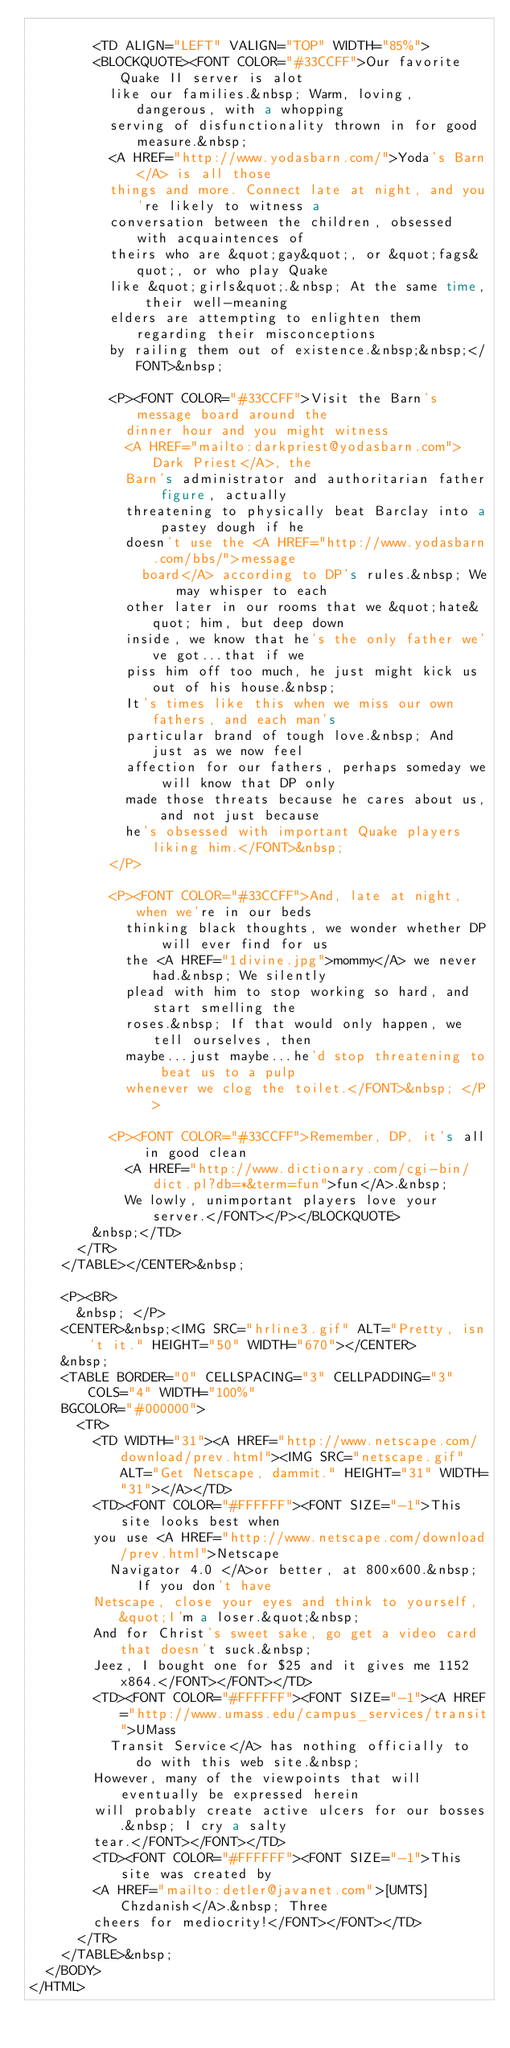Convert code to text. <code><loc_0><loc_0><loc_500><loc_500><_HTML_>
        <TD ALIGN="LEFT" VALIGN="TOP" WIDTH="85%">
        <BLOCKQUOTE><FONT COLOR="#33CCFF">Our favorite Quake II server is alot
          like our families.&nbsp; Warm, loving, dangerous, with a whopping
          serving of disfunctionality thrown in for good measure.&nbsp;
          <A HREF="http://www.yodasbarn.com/">Yoda's Barn</A> is all those
          things and more. Connect late at night, and you're likely to witness a
          conversation between the children, obsessed with acquaintences of
          theirs who are &quot;gay&quot;, or &quot;fags&quot;, or who play Quake
          like &quot;girls&quot;.&nbsp; At the same time, their well-meaning
          elders are attempting to enlighten them regarding their misconceptions
          by railing them out of existence.&nbsp;&nbsp;</FONT>&nbsp;
          
          <P><FONT COLOR="#33CCFF">Visit the Barn's message board around the
            dinner hour and you might witness
            <A HREF="mailto:darkpriest@yodasbarn.com">Dark Priest</A>, the
            Barn's administrator and authoritarian father figure, actually
            threatening to physically beat Barclay into a pastey dough if he
            doesn't use the <A HREF="http://www.yodasbarn.com/bbs/">message
              board</A> according to DP's rules.&nbsp; We may whisper to each
            other later in our rooms that we &quot;hate&quot; him, but deep down
            inside, we know that he's the only father we've got...that if we
            piss him off too much, he just might kick us out of his house.&nbsp;
            It's times like this when we miss our own fathers, and each man's
            particular brand of tough love.&nbsp; And just as we now feel
            affection for our fathers, perhaps someday we will know that DP only
            made those threats because he cares about us, and not just because
            he's obsessed with important Quake players liking him.</FONT>&nbsp;
          </P>
          
          <P><FONT COLOR="#33CCFF">And, late at night, when we're in our beds
            thinking black thoughts, we wonder whether DP will ever find for us
            the <A HREF="1divine.jpg">mommy</A> we never had.&nbsp; We silently
            plead with him to stop working so hard, and start smelling the
            roses.&nbsp; If that would only happen, we tell ourselves, then
            maybe...just maybe...he'd stop threatening to beat us to a pulp
            whenever we clog the toilet.</FONT>&nbsp; </P>
          
          <P><FONT COLOR="#33CCFF">Remember, DP, it's all in good clean
            <A HREF="http://www.dictionary.com/cgi-bin/dict.pl?db=*&term=fun">fun</A>.&nbsp;
            We lowly, unimportant players love your server.</FONT></P></BLOCKQUOTE>
        &nbsp;</TD>
      </TR>
    </TABLE></CENTER>&nbsp;
    
    <P><BR>
      &nbsp; </P>
    <CENTER>&nbsp;<IMG SRC="hrline3.gif" ALT="Pretty, isn't it." HEIGHT="50" WIDTH="670"></CENTER>
    &nbsp;
    <TABLE BORDER="0" CELLSPACING="3" CELLPADDING="3" COLS="4" WIDTH="100%" 
    BGCOLOR="#000000">
      <TR>
        <TD WIDTH="31"><A HREF="http://www.netscape.com/download/prev.html"><IMG SRC="netscape.gif" ALT="Get Netscape, dammit." HEIGHT="31" WIDTH="31"></A></TD>
        <TD><FONT COLOR="#FFFFFF"><FONT SIZE="-1">This site looks best when
        you use <A HREF="http://www.netscape.com/download/prev.html">Netscape
          Navigator 4.0 </A>or better, at 800x600.&nbsp; If you don't have
        Netscape, close your eyes and think to yourself, &quot;I'm a loser.&quot;&nbsp;
        And for Christ's sweet sake, go get a video card that doesn't suck.&nbsp;
        Jeez, I bought one for $25 and it gives me 1152x864.</FONT></FONT></TD>
        <TD><FONT COLOR="#FFFFFF"><FONT SIZE="-1"><A HREF="http://www.umass.edu/campus_services/transit">UMass
          Transit Service</A> has nothing officially to do with this web site.&nbsp;
        However, many of the viewpoints that will eventually be expressed herein
        will probably create active ulcers for our bosses.&nbsp; I cry a salty
        tear.</FONT></FONT></TD>
        <TD><FONT COLOR="#FFFFFF"><FONT SIZE="-1">This site was created by
        <A HREF="mailto:detler@javanet.com">[UMTS]Chzdanish</A>.&nbsp; Three
        cheers for mediocrity!</FONT></FONT></TD>
      </TR>
    </TABLE>&nbsp;
  </BODY>
</HTML>
</code> 